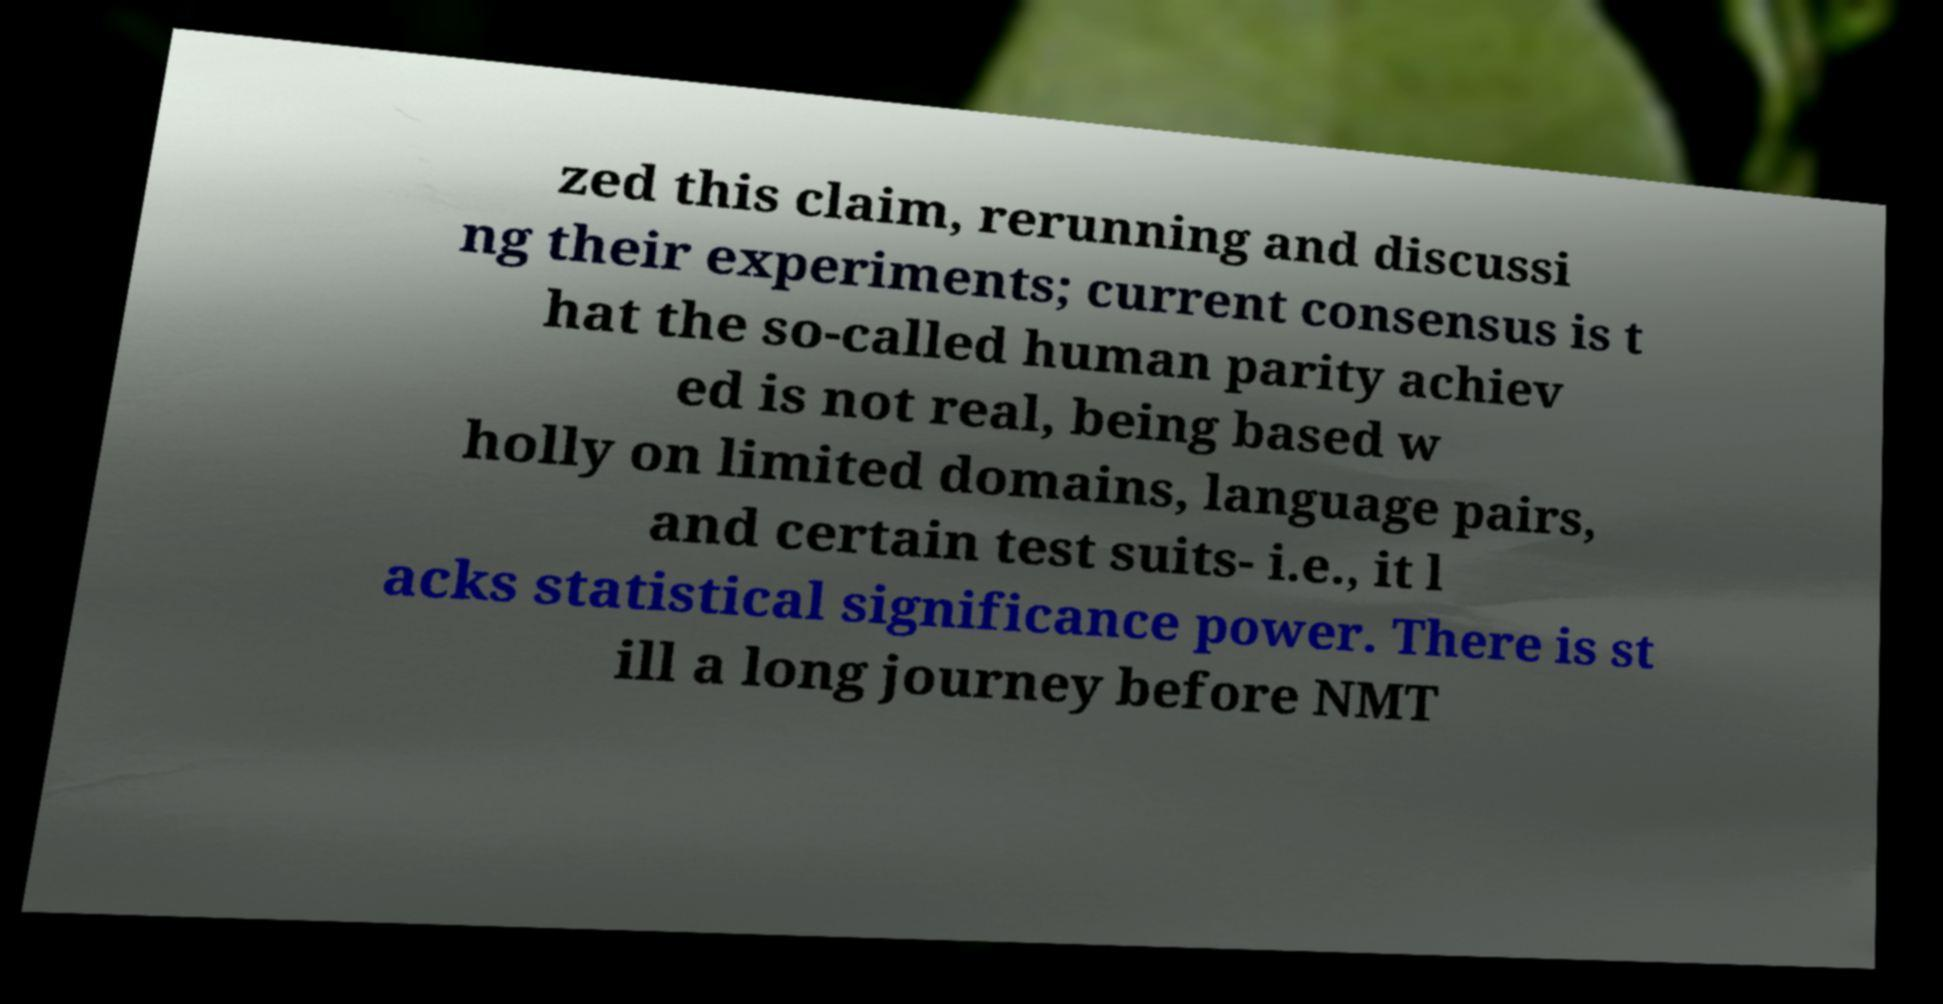For documentation purposes, I need the text within this image transcribed. Could you provide that? zed this claim, rerunning and discussi ng their experiments; current consensus is t hat the so-called human parity achiev ed is not real, being based w holly on limited domains, language pairs, and certain test suits- i.e., it l acks statistical significance power. There is st ill a long journey before NMT 